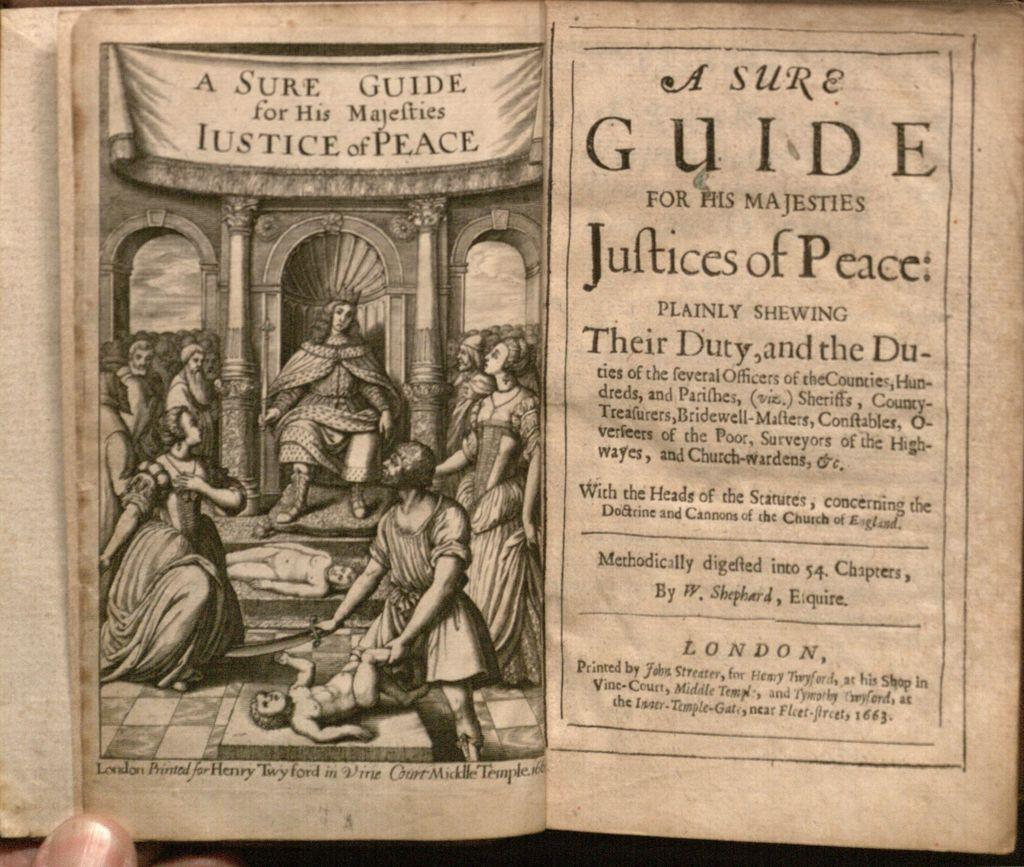Provide a one-sentence caption for the provided image. The title page of a book that was printed in London in 1663. 